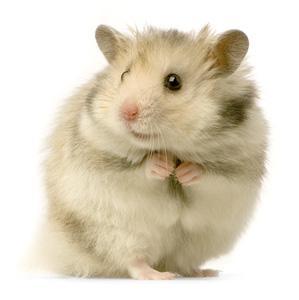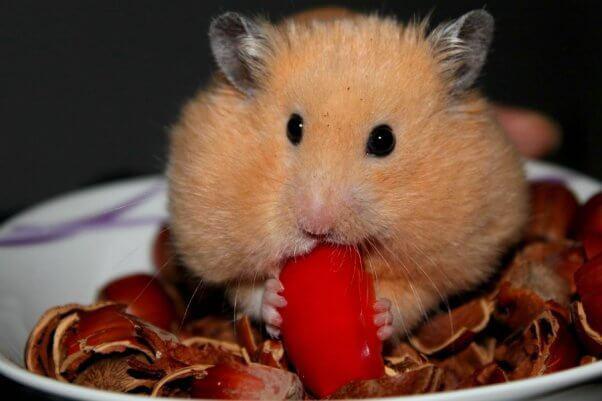The first image is the image on the left, the second image is the image on the right. For the images shown, is this caption "There is a hamster eating a carrot." true? Answer yes or no. Yes. 